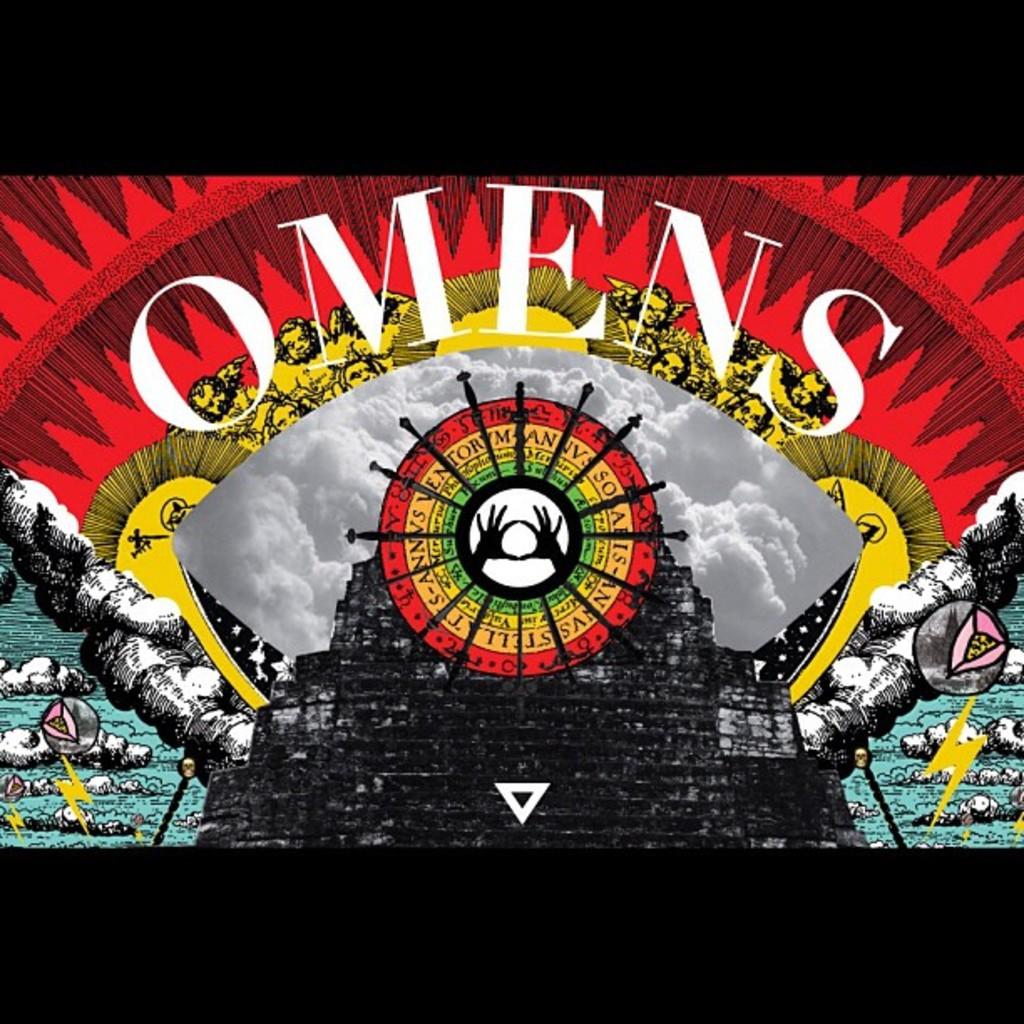What is mentioned above the two hands?
Give a very brief answer. Omens. What is the large white word?
Your response must be concise. Omens. 